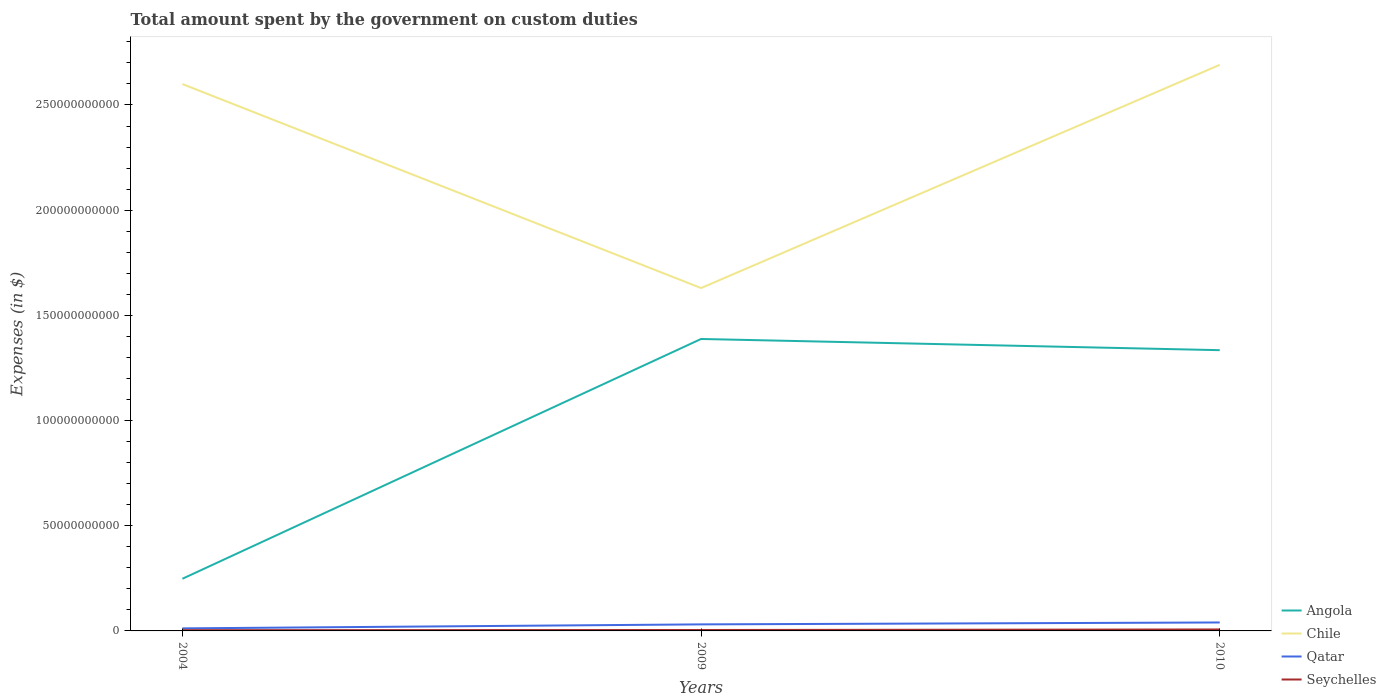Is the number of lines equal to the number of legend labels?
Give a very brief answer. Yes. Across all years, what is the maximum amount spent on custom duties by the government in Angola?
Offer a terse response. 2.48e+1. In which year was the amount spent on custom duties by the government in Seychelles maximum?
Ensure brevity in your answer.  2004. What is the total amount spent on custom duties by the government in Chile in the graph?
Provide a succinct answer. 9.70e+1. What is the difference between the highest and the second highest amount spent on custom duties by the government in Chile?
Your answer should be compact. 1.06e+11. What is the difference between the highest and the lowest amount spent on custom duties by the government in Seychelles?
Make the answer very short. 1. Is the amount spent on custom duties by the government in Chile strictly greater than the amount spent on custom duties by the government in Angola over the years?
Ensure brevity in your answer.  No. What is the difference between two consecutive major ticks on the Y-axis?
Your answer should be very brief. 5.00e+1. Where does the legend appear in the graph?
Provide a succinct answer. Bottom right. What is the title of the graph?
Provide a succinct answer. Total amount spent by the government on custom duties. Does "Benin" appear as one of the legend labels in the graph?
Your response must be concise. No. What is the label or title of the Y-axis?
Provide a short and direct response. Expenses (in $). What is the Expenses (in $) in Angola in 2004?
Make the answer very short. 2.48e+1. What is the Expenses (in $) of Chile in 2004?
Your response must be concise. 2.60e+11. What is the Expenses (in $) in Qatar in 2004?
Offer a very short reply. 1.21e+09. What is the Expenses (in $) of Seychelles in 2004?
Offer a terse response. 3.51e+08. What is the Expenses (in $) of Angola in 2009?
Your response must be concise. 1.39e+11. What is the Expenses (in $) of Chile in 2009?
Keep it short and to the point. 1.63e+11. What is the Expenses (in $) in Qatar in 2009?
Make the answer very short. 3.11e+09. What is the Expenses (in $) of Seychelles in 2009?
Provide a short and direct response. 4.37e+08. What is the Expenses (in $) of Angola in 2010?
Your response must be concise. 1.33e+11. What is the Expenses (in $) in Chile in 2010?
Your answer should be very brief. 2.69e+11. What is the Expenses (in $) in Qatar in 2010?
Your response must be concise. 4.02e+09. What is the Expenses (in $) in Seychelles in 2010?
Your answer should be very brief. 6.96e+08. Across all years, what is the maximum Expenses (in $) in Angola?
Ensure brevity in your answer.  1.39e+11. Across all years, what is the maximum Expenses (in $) of Chile?
Provide a succinct answer. 2.69e+11. Across all years, what is the maximum Expenses (in $) of Qatar?
Provide a succinct answer. 4.02e+09. Across all years, what is the maximum Expenses (in $) in Seychelles?
Keep it short and to the point. 6.96e+08. Across all years, what is the minimum Expenses (in $) in Angola?
Your answer should be very brief. 2.48e+1. Across all years, what is the minimum Expenses (in $) of Chile?
Your answer should be very brief. 1.63e+11. Across all years, what is the minimum Expenses (in $) in Qatar?
Keep it short and to the point. 1.21e+09. Across all years, what is the minimum Expenses (in $) in Seychelles?
Make the answer very short. 3.51e+08. What is the total Expenses (in $) in Angola in the graph?
Offer a terse response. 2.97e+11. What is the total Expenses (in $) in Chile in the graph?
Provide a succinct answer. 6.92e+11. What is the total Expenses (in $) of Qatar in the graph?
Make the answer very short. 8.34e+09. What is the total Expenses (in $) in Seychelles in the graph?
Ensure brevity in your answer.  1.48e+09. What is the difference between the Expenses (in $) of Angola in 2004 and that in 2009?
Your answer should be very brief. -1.14e+11. What is the difference between the Expenses (in $) in Chile in 2004 and that in 2009?
Provide a succinct answer. 9.70e+1. What is the difference between the Expenses (in $) in Qatar in 2004 and that in 2009?
Your answer should be very brief. -1.91e+09. What is the difference between the Expenses (in $) in Seychelles in 2004 and that in 2009?
Keep it short and to the point. -8.59e+07. What is the difference between the Expenses (in $) in Angola in 2004 and that in 2010?
Give a very brief answer. -1.09e+11. What is the difference between the Expenses (in $) of Chile in 2004 and that in 2010?
Give a very brief answer. -9.14e+09. What is the difference between the Expenses (in $) in Qatar in 2004 and that in 2010?
Give a very brief answer. -2.81e+09. What is the difference between the Expenses (in $) in Seychelles in 2004 and that in 2010?
Offer a very short reply. -3.44e+08. What is the difference between the Expenses (in $) in Angola in 2009 and that in 2010?
Your answer should be compact. 5.33e+09. What is the difference between the Expenses (in $) of Chile in 2009 and that in 2010?
Ensure brevity in your answer.  -1.06e+11. What is the difference between the Expenses (in $) in Qatar in 2009 and that in 2010?
Keep it short and to the point. -9.05e+08. What is the difference between the Expenses (in $) of Seychelles in 2009 and that in 2010?
Your answer should be very brief. -2.58e+08. What is the difference between the Expenses (in $) of Angola in 2004 and the Expenses (in $) of Chile in 2009?
Keep it short and to the point. -1.38e+11. What is the difference between the Expenses (in $) in Angola in 2004 and the Expenses (in $) in Qatar in 2009?
Provide a short and direct response. 2.17e+1. What is the difference between the Expenses (in $) in Angola in 2004 and the Expenses (in $) in Seychelles in 2009?
Give a very brief answer. 2.44e+1. What is the difference between the Expenses (in $) of Chile in 2004 and the Expenses (in $) of Qatar in 2009?
Provide a short and direct response. 2.57e+11. What is the difference between the Expenses (in $) of Chile in 2004 and the Expenses (in $) of Seychelles in 2009?
Make the answer very short. 2.60e+11. What is the difference between the Expenses (in $) in Qatar in 2004 and the Expenses (in $) in Seychelles in 2009?
Your answer should be compact. 7.70e+08. What is the difference between the Expenses (in $) in Angola in 2004 and the Expenses (in $) in Chile in 2010?
Offer a terse response. -2.44e+11. What is the difference between the Expenses (in $) of Angola in 2004 and the Expenses (in $) of Qatar in 2010?
Ensure brevity in your answer.  2.08e+1. What is the difference between the Expenses (in $) of Angola in 2004 and the Expenses (in $) of Seychelles in 2010?
Your response must be concise. 2.41e+1. What is the difference between the Expenses (in $) in Chile in 2004 and the Expenses (in $) in Qatar in 2010?
Make the answer very short. 2.56e+11. What is the difference between the Expenses (in $) in Chile in 2004 and the Expenses (in $) in Seychelles in 2010?
Provide a succinct answer. 2.59e+11. What is the difference between the Expenses (in $) of Qatar in 2004 and the Expenses (in $) of Seychelles in 2010?
Provide a short and direct response. 5.11e+08. What is the difference between the Expenses (in $) of Angola in 2009 and the Expenses (in $) of Chile in 2010?
Your answer should be compact. -1.30e+11. What is the difference between the Expenses (in $) of Angola in 2009 and the Expenses (in $) of Qatar in 2010?
Your answer should be compact. 1.35e+11. What is the difference between the Expenses (in $) of Angola in 2009 and the Expenses (in $) of Seychelles in 2010?
Offer a very short reply. 1.38e+11. What is the difference between the Expenses (in $) of Chile in 2009 and the Expenses (in $) of Qatar in 2010?
Offer a terse response. 1.59e+11. What is the difference between the Expenses (in $) in Chile in 2009 and the Expenses (in $) in Seychelles in 2010?
Give a very brief answer. 1.62e+11. What is the difference between the Expenses (in $) in Qatar in 2009 and the Expenses (in $) in Seychelles in 2010?
Your response must be concise. 2.42e+09. What is the average Expenses (in $) of Angola per year?
Offer a very short reply. 9.90e+1. What is the average Expenses (in $) in Chile per year?
Your answer should be very brief. 2.31e+11. What is the average Expenses (in $) of Qatar per year?
Ensure brevity in your answer.  2.78e+09. What is the average Expenses (in $) in Seychelles per year?
Your answer should be compact. 4.95e+08. In the year 2004, what is the difference between the Expenses (in $) in Angola and Expenses (in $) in Chile?
Give a very brief answer. -2.35e+11. In the year 2004, what is the difference between the Expenses (in $) in Angola and Expenses (in $) in Qatar?
Your answer should be compact. 2.36e+1. In the year 2004, what is the difference between the Expenses (in $) of Angola and Expenses (in $) of Seychelles?
Keep it short and to the point. 2.44e+1. In the year 2004, what is the difference between the Expenses (in $) in Chile and Expenses (in $) in Qatar?
Give a very brief answer. 2.59e+11. In the year 2004, what is the difference between the Expenses (in $) in Chile and Expenses (in $) in Seychelles?
Make the answer very short. 2.60e+11. In the year 2004, what is the difference between the Expenses (in $) of Qatar and Expenses (in $) of Seychelles?
Offer a terse response. 8.56e+08. In the year 2009, what is the difference between the Expenses (in $) of Angola and Expenses (in $) of Chile?
Ensure brevity in your answer.  -2.42e+1. In the year 2009, what is the difference between the Expenses (in $) of Angola and Expenses (in $) of Qatar?
Provide a short and direct response. 1.36e+11. In the year 2009, what is the difference between the Expenses (in $) of Angola and Expenses (in $) of Seychelles?
Your response must be concise. 1.38e+11. In the year 2009, what is the difference between the Expenses (in $) in Chile and Expenses (in $) in Qatar?
Your response must be concise. 1.60e+11. In the year 2009, what is the difference between the Expenses (in $) of Chile and Expenses (in $) of Seychelles?
Provide a short and direct response. 1.63e+11. In the year 2009, what is the difference between the Expenses (in $) in Qatar and Expenses (in $) in Seychelles?
Provide a short and direct response. 2.68e+09. In the year 2010, what is the difference between the Expenses (in $) in Angola and Expenses (in $) in Chile?
Offer a very short reply. -1.36e+11. In the year 2010, what is the difference between the Expenses (in $) of Angola and Expenses (in $) of Qatar?
Provide a succinct answer. 1.29e+11. In the year 2010, what is the difference between the Expenses (in $) of Angola and Expenses (in $) of Seychelles?
Make the answer very short. 1.33e+11. In the year 2010, what is the difference between the Expenses (in $) in Chile and Expenses (in $) in Qatar?
Offer a terse response. 2.65e+11. In the year 2010, what is the difference between the Expenses (in $) in Chile and Expenses (in $) in Seychelles?
Your response must be concise. 2.68e+11. In the year 2010, what is the difference between the Expenses (in $) in Qatar and Expenses (in $) in Seychelles?
Provide a succinct answer. 3.32e+09. What is the ratio of the Expenses (in $) of Angola in 2004 to that in 2009?
Ensure brevity in your answer.  0.18. What is the ratio of the Expenses (in $) of Chile in 2004 to that in 2009?
Offer a terse response. 1.59. What is the ratio of the Expenses (in $) of Qatar in 2004 to that in 2009?
Ensure brevity in your answer.  0.39. What is the ratio of the Expenses (in $) in Seychelles in 2004 to that in 2009?
Your response must be concise. 0.8. What is the ratio of the Expenses (in $) in Angola in 2004 to that in 2010?
Provide a succinct answer. 0.19. What is the ratio of the Expenses (in $) of Chile in 2004 to that in 2010?
Your response must be concise. 0.97. What is the ratio of the Expenses (in $) in Qatar in 2004 to that in 2010?
Your answer should be compact. 0.3. What is the ratio of the Expenses (in $) in Seychelles in 2004 to that in 2010?
Offer a terse response. 0.5. What is the ratio of the Expenses (in $) of Angola in 2009 to that in 2010?
Provide a succinct answer. 1.04. What is the ratio of the Expenses (in $) of Chile in 2009 to that in 2010?
Offer a very short reply. 0.61. What is the ratio of the Expenses (in $) in Qatar in 2009 to that in 2010?
Provide a succinct answer. 0.77. What is the ratio of the Expenses (in $) in Seychelles in 2009 to that in 2010?
Your answer should be compact. 0.63. What is the difference between the highest and the second highest Expenses (in $) of Angola?
Your answer should be very brief. 5.33e+09. What is the difference between the highest and the second highest Expenses (in $) in Chile?
Your response must be concise. 9.14e+09. What is the difference between the highest and the second highest Expenses (in $) in Qatar?
Make the answer very short. 9.05e+08. What is the difference between the highest and the second highest Expenses (in $) in Seychelles?
Your answer should be compact. 2.58e+08. What is the difference between the highest and the lowest Expenses (in $) of Angola?
Your answer should be compact. 1.14e+11. What is the difference between the highest and the lowest Expenses (in $) in Chile?
Keep it short and to the point. 1.06e+11. What is the difference between the highest and the lowest Expenses (in $) in Qatar?
Give a very brief answer. 2.81e+09. What is the difference between the highest and the lowest Expenses (in $) in Seychelles?
Your answer should be very brief. 3.44e+08. 